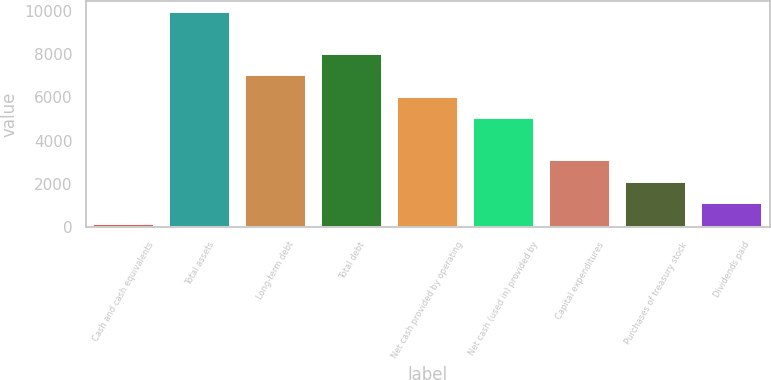Convert chart. <chart><loc_0><loc_0><loc_500><loc_500><bar_chart><fcel>Cash and cash equivalents<fcel>Total assets<fcel>Long-term debt<fcel>Total debt<fcel>Net cash provided by operating<fcel>Net cash (used in) provided by<fcel>Capital expenditures<fcel>Purchases of treasury stock<fcel>Dividends paid<nl><fcel>133<fcel>9962<fcel>7013.3<fcel>7996.2<fcel>6030.4<fcel>5047.5<fcel>3081.7<fcel>2098.8<fcel>1115.9<nl></chart> 